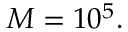Convert formula to latex. <formula><loc_0><loc_0><loc_500><loc_500>M = 1 0 ^ { 5 } .</formula> 